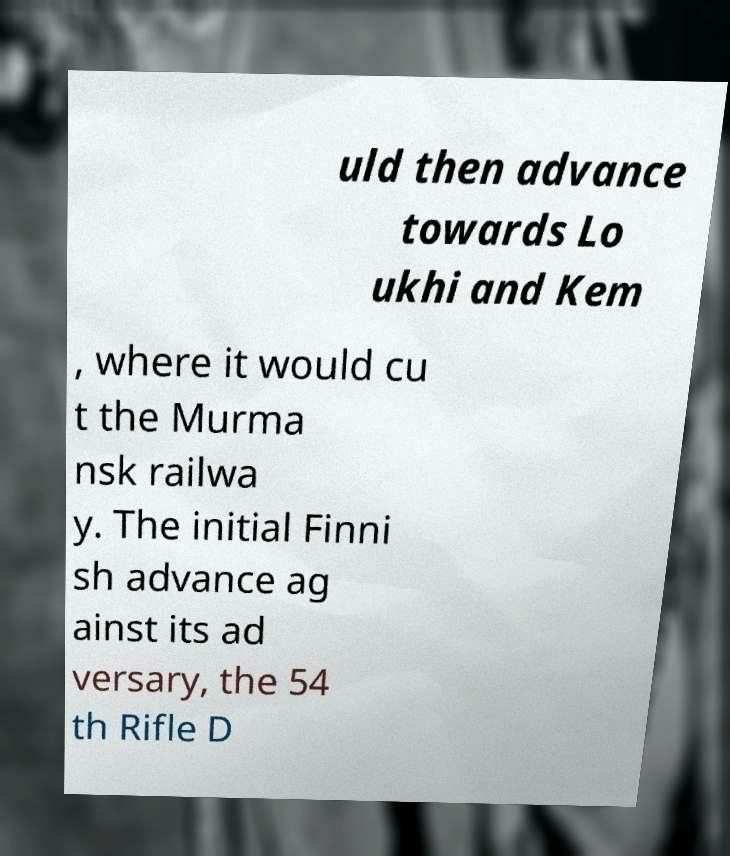Could you assist in decoding the text presented in this image and type it out clearly? uld then advance towards Lo ukhi and Kem , where it would cu t the Murma nsk railwa y. The initial Finni sh advance ag ainst its ad versary, the 54 th Rifle D 